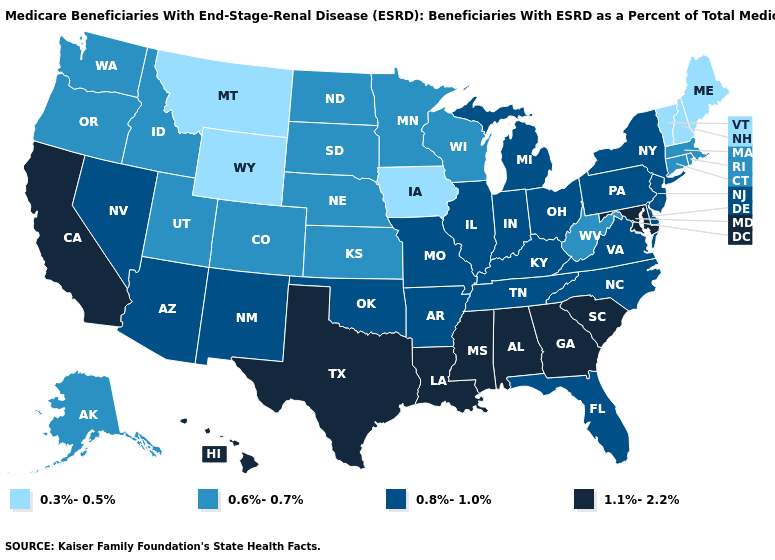Does Utah have the highest value in the USA?
Give a very brief answer. No. What is the lowest value in the Northeast?
Answer briefly. 0.3%-0.5%. Name the states that have a value in the range 0.3%-0.5%?
Give a very brief answer. Iowa, Maine, Montana, New Hampshire, Vermont, Wyoming. What is the value of Iowa?
Quick response, please. 0.3%-0.5%. How many symbols are there in the legend?
Concise answer only. 4. What is the value of Pennsylvania?
Give a very brief answer. 0.8%-1.0%. Which states have the highest value in the USA?
Short answer required. Alabama, California, Georgia, Hawaii, Louisiana, Maryland, Mississippi, South Carolina, Texas. What is the highest value in states that border Texas?
Quick response, please. 1.1%-2.2%. Name the states that have a value in the range 0.3%-0.5%?
Give a very brief answer. Iowa, Maine, Montana, New Hampshire, Vermont, Wyoming. Does New Jersey have the highest value in the USA?
Be succinct. No. What is the value of Colorado?
Concise answer only. 0.6%-0.7%. Name the states that have a value in the range 0.6%-0.7%?
Keep it brief. Alaska, Colorado, Connecticut, Idaho, Kansas, Massachusetts, Minnesota, Nebraska, North Dakota, Oregon, Rhode Island, South Dakota, Utah, Washington, West Virginia, Wisconsin. What is the value of Minnesota?
Write a very short answer. 0.6%-0.7%. Name the states that have a value in the range 0.6%-0.7%?
Concise answer only. Alaska, Colorado, Connecticut, Idaho, Kansas, Massachusetts, Minnesota, Nebraska, North Dakota, Oregon, Rhode Island, South Dakota, Utah, Washington, West Virginia, Wisconsin. What is the value of Delaware?
Keep it brief. 0.8%-1.0%. 